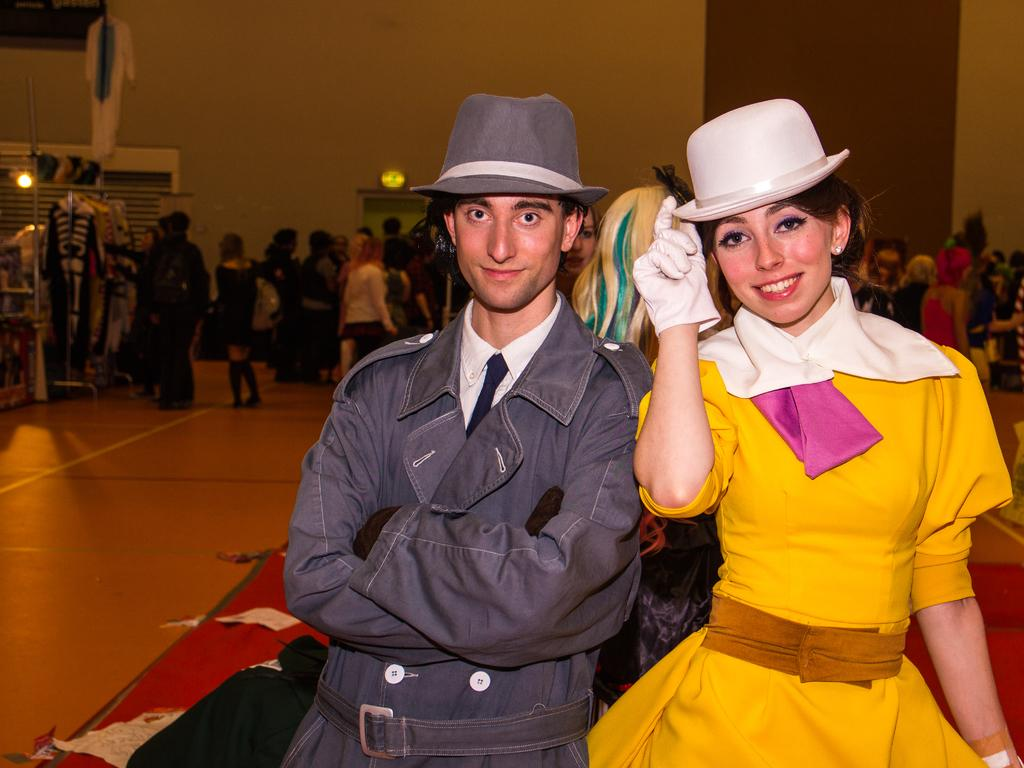What is the primary subject in the image? There is a person standing in the image. Can you describe the scene in the background? In the background of the image, there is a group of persons, clothes, a door, a window, and a wall. How many people are visible in the image? There is one person standing in the image, and a group of persons in the background. What type of pies can be seen on the person's foot in the image? There are no pies or feet visible in the image; it only features a person standing and a background scene. 